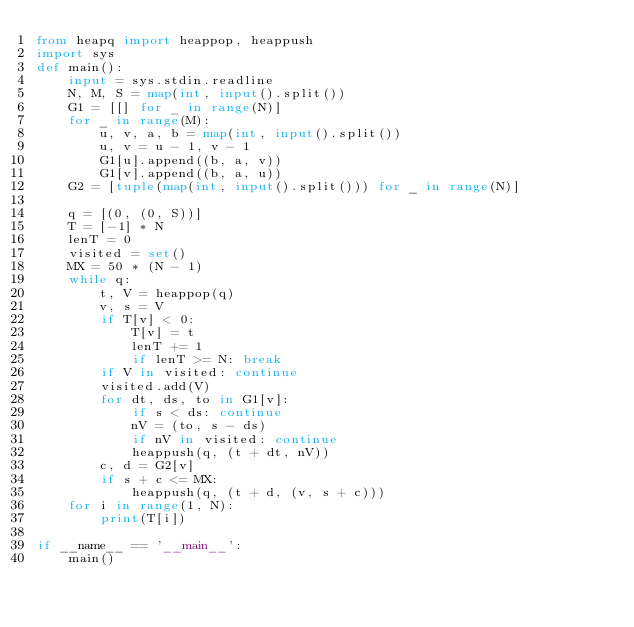Convert code to text. <code><loc_0><loc_0><loc_500><loc_500><_Python_>from heapq import heappop, heappush
import sys
def main():
    input = sys.stdin.readline
    N, M, S = map(int, input().split())
    G1 = [[] for _ in range(N)]
    for _ in range(M):
        u, v, a, b = map(int, input().split())
        u, v = u - 1, v - 1
        G1[u].append((b, a, v))
        G1[v].append((b, a, u))
    G2 = [tuple(map(int, input().split())) for _ in range(N)]

    q = [(0, (0, S))]
    T = [-1] * N
    lenT = 0
    visited = set()
    MX = 50 * (N - 1)
    while q:
        t, V = heappop(q)
        v, s = V
        if T[v] < 0:
            T[v] = t
            lenT += 1
            if lenT >= N: break
        if V in visited: continue
        visited.add(V)
        for dt, ds, to in G1[v]:
            if s < ds: continue
            nV = (to, s - ds)
            if nV in visited: continue
            heappush(q, (t + dt, nV))
        c, d = G2[v]
        if s + c <= MX:
            heappush(q, (t + d, (v, s + c)))
    for i in range(1, N):
        print(T[i])

if __name__ == '__main__':
    main()
</code> 